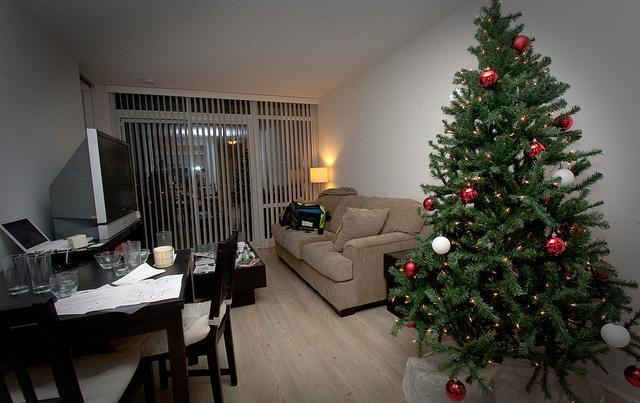How many presents are under the tree?
Give a very brief answer. 0. How many lamps are off?
Give a very brief answer. 0. How many pillows are on the sofa?
Give a very brief answer. 1. How many chairs are there?
Give a very brief answer. 2. How many donuts are visible?
Give a very brief answer. 0. 